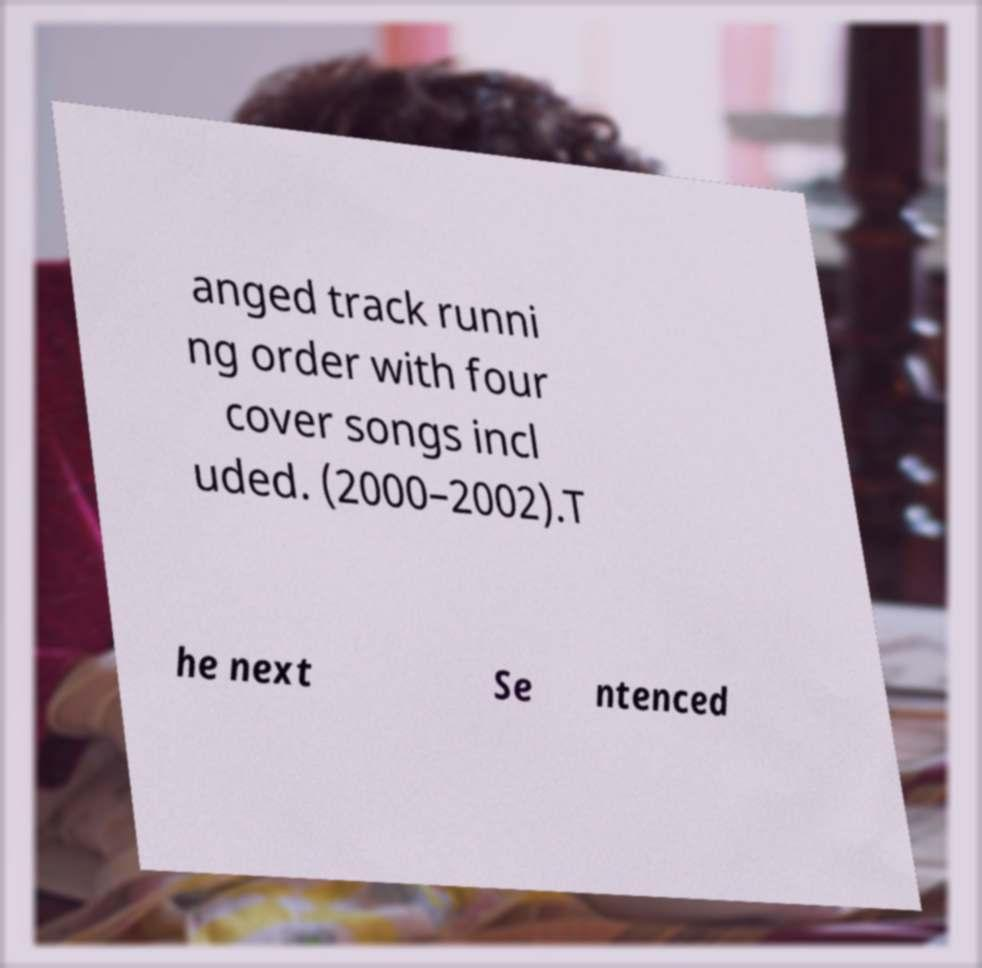Please read and relay the text visible in this image. What does it say? anged track runni ng order with four cover songs incl uded. (2000–2002).T he next Se ntenced 